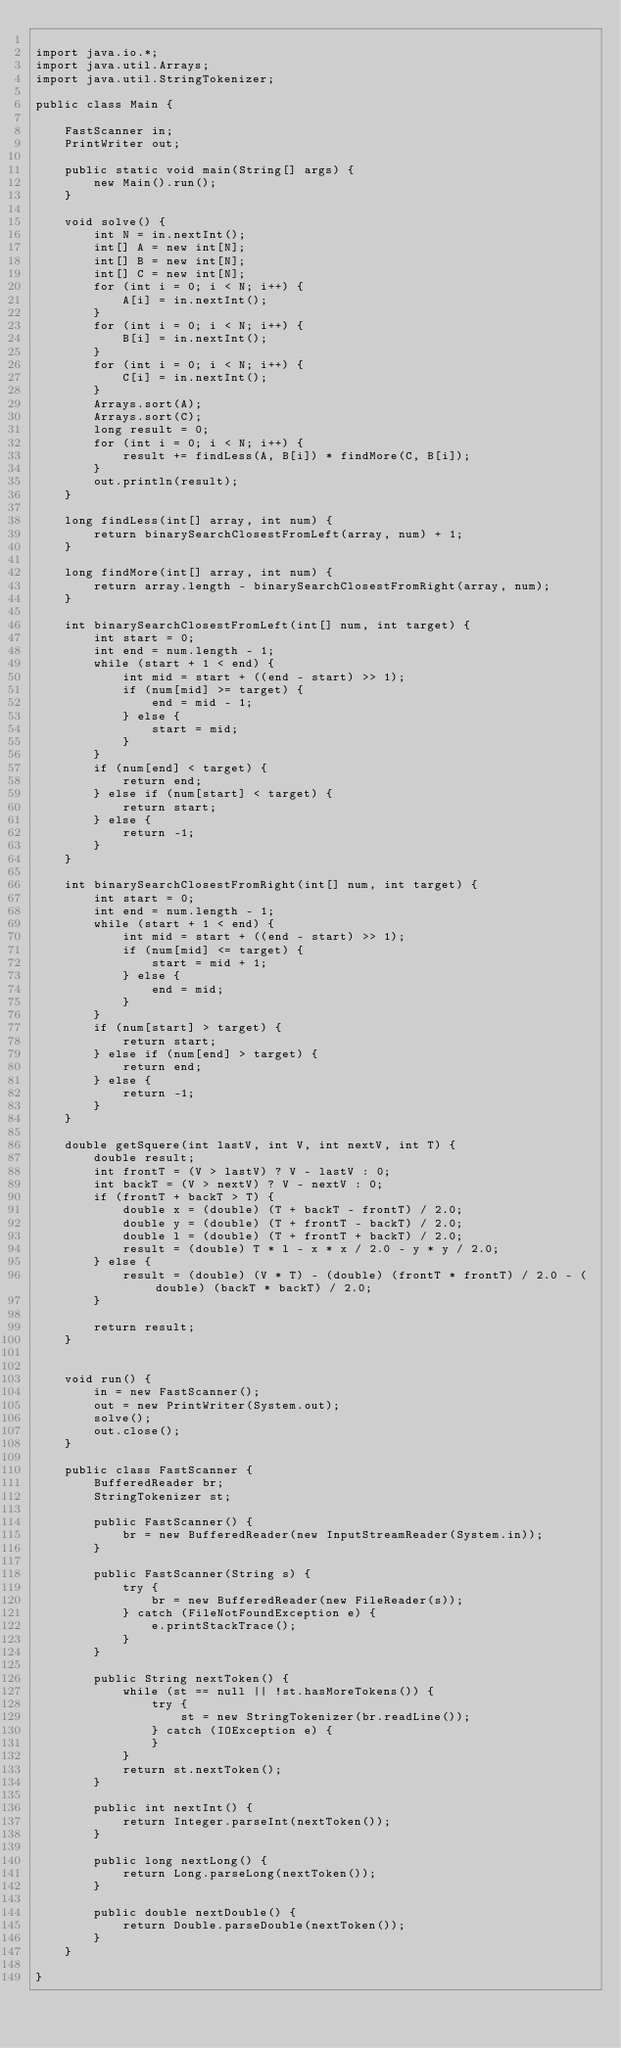Convert code to text. <code><loc_0><loc_0><loc_500><loc_500><_Java_>
import java.io.*;
import java.util.Arrays;
import java.util.StringTokenizer;

public class Main {

    FastScanner in;
    PrintWriter out;

    public static void main(String[] args) {
        new Main().run();
    }

    void solve() {
        int N = in.nextInt();
        int[] A = new int[N];
        int[] B = new int[N];
        int[] C = new int[N];
        for (int i = 0; i < N; i++) {
            A[i] = in.nextInt();
        }
        for (int i = 0; i < N; i++) {
            B[i] = in.nextInt();
        }
        for (int i = 0; i < N; i++) {
            C[i] = in.nextInt();
        }
        Arrays.sort(A);
        Arrays.sort(C);
        long result = 0;
        for (int i = 0; i < N; i++) {
            result += findLess(A, B[i]) * findMore(C, B[i]);
        }
        out.println(result);
    }

    long findLess(int[] array, int num) {
        return binarySearchClosestFromLeft(array, num) + 1;
    }

    long findMore(int[] array, int num) {
        return array.length - binarySearchClosestFromRight(array, num);
    }

    int binarySearchClosestFromLeft(int[] num, int target) {
        int start = 0;
        int end = num.length - 1;
        while (start + 1 < end) {
            int mid = start + ((end - start) >> 1);
            if (num[mid] >= target) {
                end = mid - 1;
            } else {
                start = mid;
            }
        }
        if (num[end] < target) {
            return end;
        } else if (num[start] < target) {
            return start;
        } else {
            return -1;
        }
    }

    int binarySearchClosestFromRight(int[] num, int target) {
        int start = 0;
        int end = num.length - 1;
        while (start + 1 < end) {
            int mid = start + ((end - start) >> 1);
            if (num[mid] <= target) {
                start = mid + 1;
            } else {
                end = mid;
            }
        }
        if (num[start] > target) {
            return start;
        } else if (num[end] > target) {
            return end;
        } else {
            return -1;
        }
    }

    double getSquere(int lastV, int V, int nextV, int T) {
        double result;
        int frontT = (V > lastV) ? V - lastV : 0;
        int backT = (V > nextV) ? V - nextV : 0;
        if (frontT + backT > T) {
            double x = (double) (T + backT - frontT) / 2.0;
            double y = (double) (T + frontT - backT) / 2.0;
            double l = (double) (T + frontT + backT) / 2.0;
            result = (double) T * l - x * x / 2.0 - y * y / 2.0;
        } else {
            result = (double) (V * T) - (double) (frontT * frontT) / 2.0 - (double) (backT * backT) / 2.0;
        }

        return result;
    }


    void run() {
        in = new FastScanner();
        out = new PrintWriter(System.out);
        solve();
        out.close();
    }

    public class FastScanner {
        BufferedReader br;
        StringTokenizer st;

        public FastScanner() {
            br = new BufferedReader(new InputStreamReader(System.in));
        }

        public FastScanner(String s) {
            try {
                br = new BufferedReader(new FileReader(s));
            } catch (FileNotFoundException e) {
                e.printStackTrace();
            }
        }

        public String nextToken() {
            while (st == null || !st.hasMoreTokens()) {
                try {
                    st = new StringTokenizer(br.readLine());
                } catch (IOException e) {
                }
            }
            return st.nextToken();
        }

        public int nextInt() {
            return Integer.parseInt(nextToken());
        }

        public long nextLong() {
            return Long.parseLong(nextToken());
        }

        public double nextDouble() {
            return Double.parseDouble(nextToken());
        }
    }

}</code> 